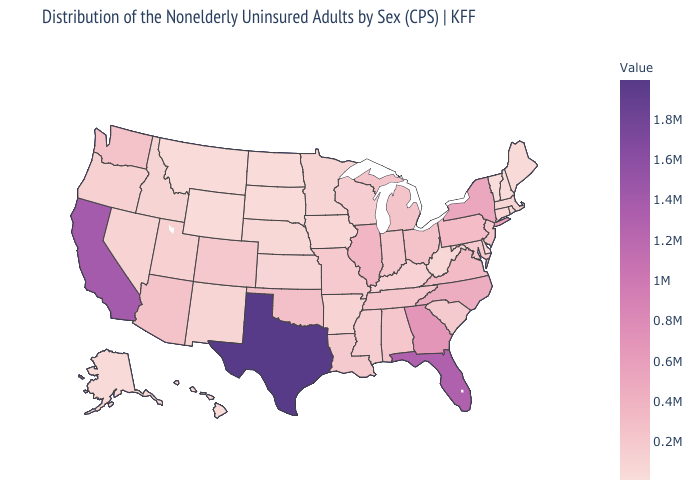Does Texas have the highest value in the USA?
Write a very short answer. Yes. Among the states that border New York , which have the lowest value?
Answer briefly. Vermont. Among the states that border Louisiana , does Arkansas have the lowest value?
Short answer required. Yes. Does the map have missing data?
Be succinct. No. Does Missouri have the lowest value in the USA?
Be succinct. No. Does the map have missing data?
Answer briefly. No. Is the legend a continuous bar?
Answer briefly. Yes. 